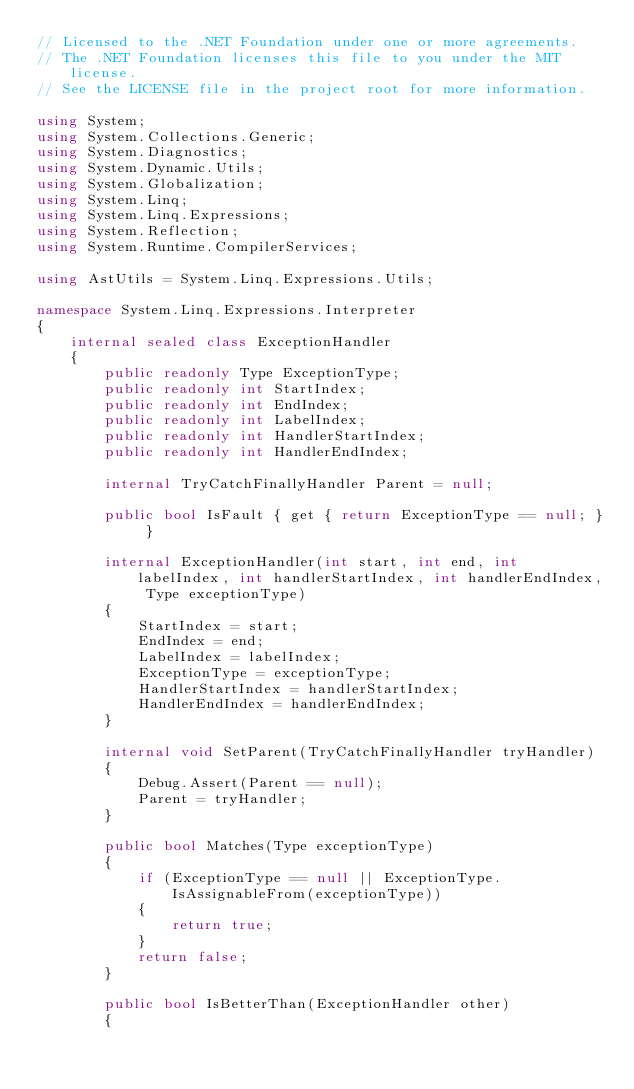Convert code to text. <code><loc_0><loc_0><loc_500><loc_500><_C#_>// Licensed to the .NET Foundation under one or more agreements.
// The .NET Foundation licenses this file to you under the MIT license.
// See the LICENSE file in the project root for more information.

using System;
using System.Collections.Generic;
using System.Diagnostics;
using System.Dynamic.Utils;
using System.Globalization;
using System.Linq;
using System.Linq.Expressions;
using System.Reflection;
using System.Runtime.CompilerServices;

using AstUtils = System.Linq.Expressions.Utils;

namespace System.Linq.Expressions.Interpreter
{
    internal sealed class ExceptionHandler
    {
        public readonly Type ExceptionType;
        public readonly int StartIndex;
        public readonly int EndIndex;
        public readonly int LabelIndex;
        public readonly int HandlerStartIndex;
        public readonly int HandlerEndIndex;

        internal TryCatchFinallyHandler Parent = null;

        public bool IsFault { get { return ExceptionType == null; } }

        internal ExceptionHandler(int start, int end, int labelIndex, int handlerStartIndex, int handlerEndIndex, Type exceptionType)
        {
            StartIndex = start;
            EndIndex = end;
            LabelIndex = labelIndex;
            ExceptionType = exceptionType;
            HandlerStartIndex = handlerStartIndex;
            HandlerEndIndex = handlerEndIndex;
        }

        internal void SetParent(TryCatchFinallyHandler tryHandler)
        {
            Debug.Assert(Parent == null);
            Parent = tryHandler;
        }

        public bool Matches(Type exceptionType)
        {
            if (ExceptionType == null || ExceptionType.IsAssignableFrom(exceptionType))
            {
                return true;
            }
            return false;
        }

        public bool IsBetterThan(ExceptionHandler other)
        {</code> 